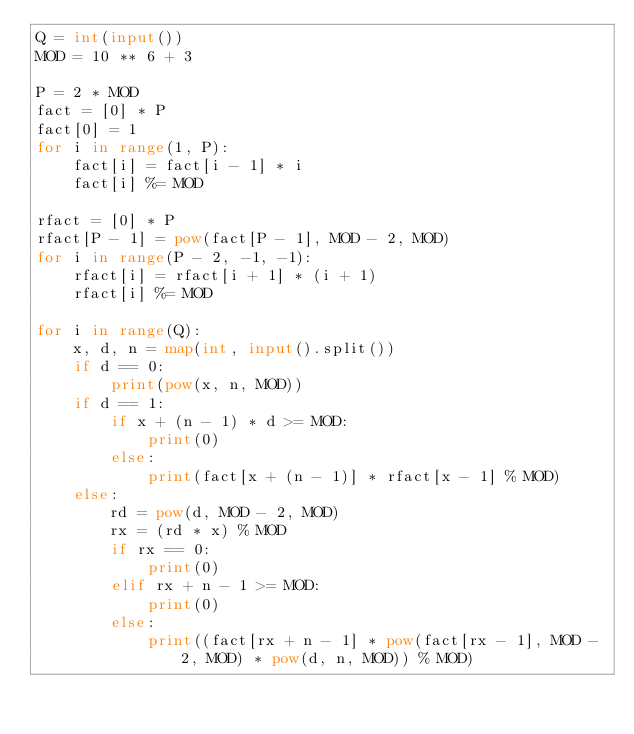Convert code to text. <code><loc_0><loc_0><loc_500><loc_500><_Python_>Q = int(input())
MOD = 10 ** 6 + 3

P = 2 * MOD
fact = [0] * P
fact[0] = 1
for i in range(1, P):
    fact[i] = fact[i - 1] * i
    fact[i] %= MOD

rfact = [0] * P
rfact[P - 1] = pow(fact[P - 1], MOD - 2, MOD)
for i in range(P - 2, -1, -1):
    rfact[i] = rfact[i + 1] * (i + 1)
    rfact[i] %= MOD

for i in range(Q):
    x, d, n = map(int, input().split())
    if d == 0:
        print(pow(x, n, MOD))
    if d == 1:
        if x + (n - 1) * d >= MOD:
            print(0)
        else:
            print(fact[x + (n - 1)] * rfact[x - 1] % MOD)
    else:
        rd = pow(d, MOD - 2, MOD)
        rx = (rd * x) % MOD
        if rx == 0:
            print(0)
        elif rx + n - 1 >= MOD:
            print(0)
        else:
            print((fact[rx + n - 1] * pow(fact[rx - 1], MOD - 2, MOD) * pow(d, n, MOD)) % MOD)</code> 